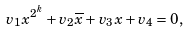Convert formula to latex. <formula><loc_0><loc_0><loc_500><loc_500>v _ { 1 } x ^ { 2 ^ { k } } + v _ { 2 } \overline { x } + v _ { 3 } x + v _ { 4 } = 0 ,</formula> 